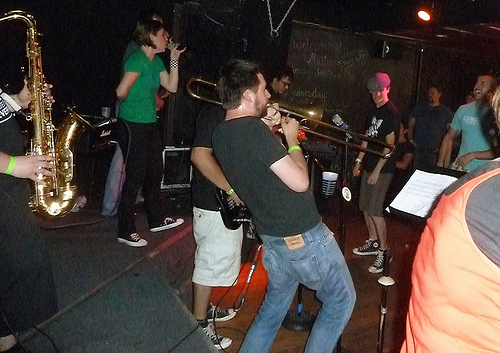<image>
Can you confirm if the man is in front of the man? Yes. The man is positioned in front of the man, appearing closer to the camera viewpoint. 